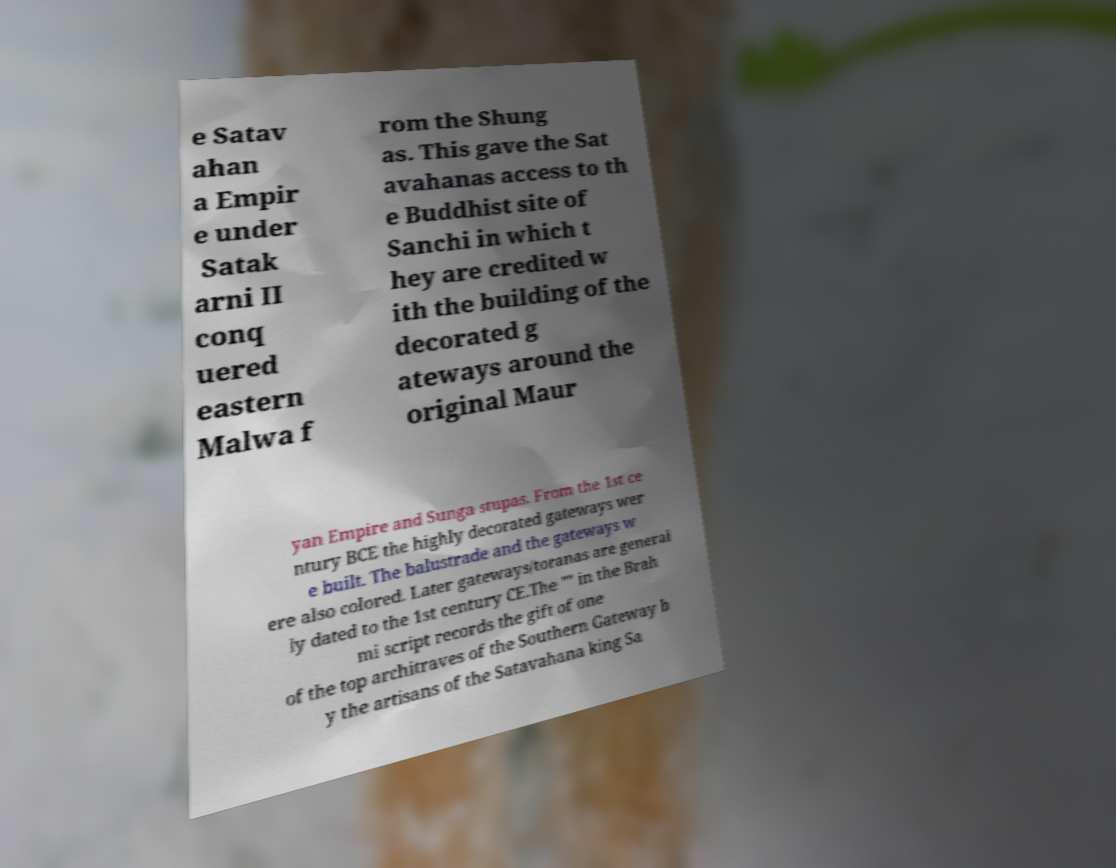What messages or text are displayed in this image? I need them in a readable, typed format. e Satav ahan a Empir e under Satak arni II conq uered eastern Malwa f rom the Shung as. This gave the Sat avahanas access to th e Buddhist site of Sanchi in which t hey are credited w ith the building of the decorated g ateways around the original Maur yan Empire and Sunga stupas. From the 1st ce ntury BCE the highly decorated gateways wer e built. The balustrade and the gateways w ere also colored. Later gateways/toranas are general ly dated to the 1st century CE.The "" in the Brah mi script records the gift of one of the top architraves of the Southern Gateway b y the artisans of the Satavahana king Sa 